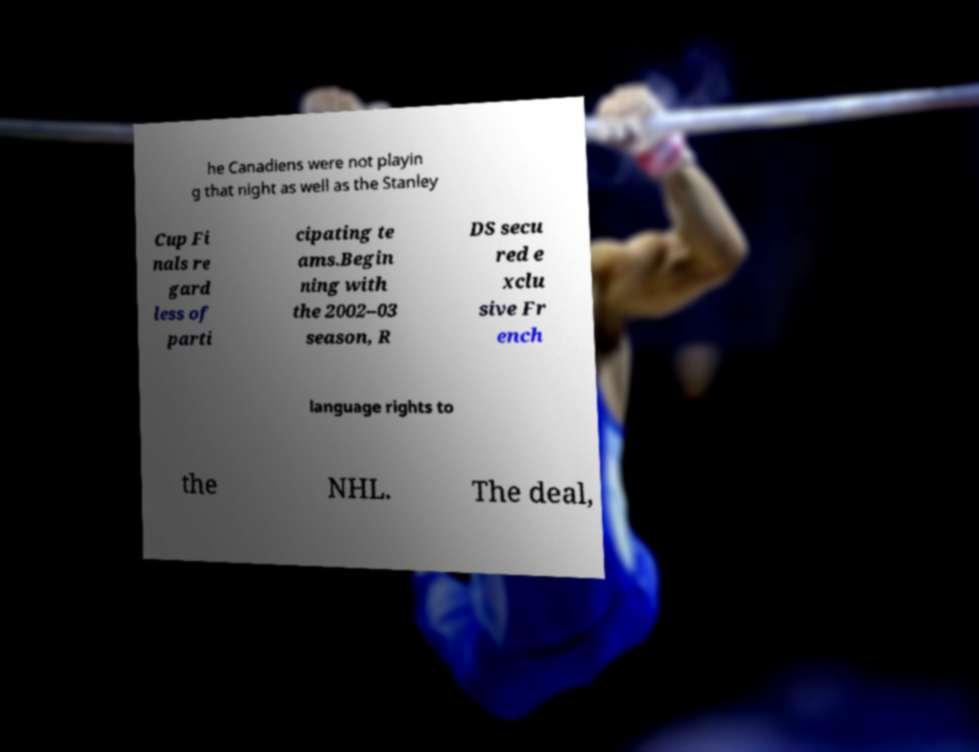Please identify and transcribe the text found in this image. he Canadiens were not playin g that night as well as the Stanley Cup Fi nals re gard less of parti cipating te ams.Begin ning with the 2002–03 season, R DS secu red e xclu sive Fr ench language rights to the NHL. The deal, 